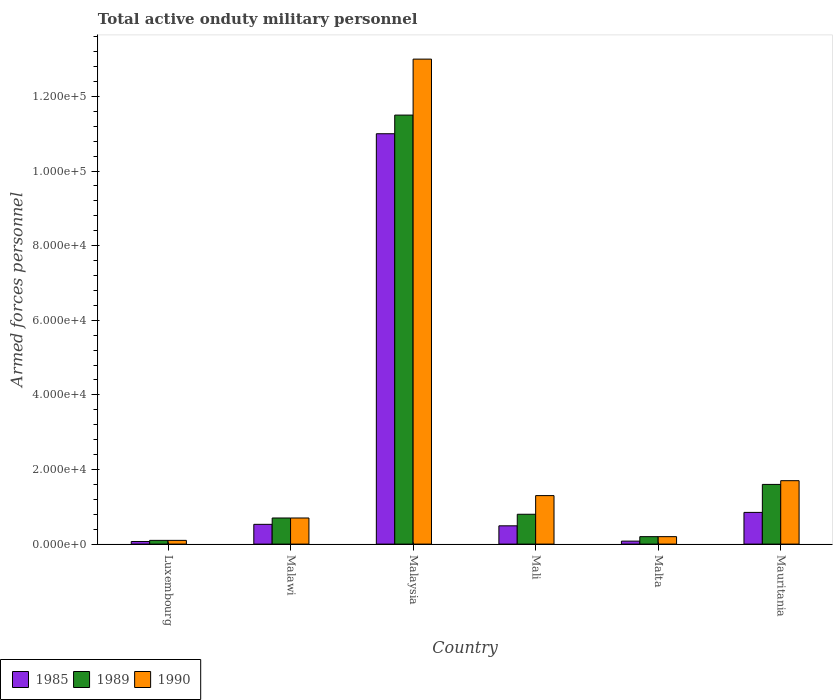Are the number of bars per tick equal to the number of legend labels?
Offer a very short reply. Yes. Are the number of bars on each tick of the X-axis equal?
Give a very brief answer. Yes. What is the label of the 6th group of bars from the left?
Keep it short and to the point. Mauritania. What is the number of armed forces personnel in 1989 in Luxembourg?
Your answer should be compact. 1000. Across all countries, what is the maximum number of armed forces personnel in 1985?
Give a very brief answer. 1.10e+05. In which country was the number of armed forces personnel in 1990 maximum?
Your answer should be compact. Malaysia. In which country was the number of armed forces personnel in 1990 minimum?
Give a very brief answer. Luxembourg. What is the total number of armed forces personnel in 1985 in the graph?
Offer a very short reply. 1.30e+05. What is the difference between the number of armed forces personnel in 1989 in Luxembourg and that in Malta?
Provide a succinct answer. -1000. What is the difference between the number of armed forces personnel in 1989 in Mali and the number of armed forces personnel in 1985 in Malawi?
Keep it short and to the point. 2700. What is the average number of armed forces personnel in 1985 per country?
Make the answer very short. 2.17e+04. What is the difference between the number of armed forces personnel of/in 1985 and number of armed forces personnel of/in 1990 in Malta?
Ensure brevity in your answer.  -1200. What is the difference between the highest and the second highest number of armed forces personnel in 1985?
Your response must be concise. 1.05e+05. What is the difference between the highest and the lowest number of armed forces personnel in 1990?
Ensure brevity in your answer.  1.29e+05. Is the sum of the number of armed forces personnel in 1990 in Luxembourg and Malaysia greater than the maximum number of armed forces personnel in 1985 across all countries?
Your answer should be compact. Yes. What does the 3rd bar from the left in Malaysia represents?
Ensure brevity in your answer.  1990. Is it the case that in every country, the sum of the number of armed forces personnel in 1990 and number of armed forces personnel in 1985 is greater than the number of armed forces personnel in 1989?
Your response must be concise. Yes. How many bars are there?
Make the answer very short. 18. Are all the bars in the graph horizontal?
Provide a succinct answer. No. How many countries are there in the graph?
Provide a succinct answer. 6. Where does the legend appear in the graph?
Give a very brief answer. Bottom left. How many legend labels are there?
Give a very brief answer. 3. How are the legend labels stacked?
Provide a short and direct response. Horizontal. What is the title of the graph?
Keep it short and to the point. Total active onduty military personnel. What is the label or title of the X-axis?
Your answer should be compact. Country. What is the label or title of the Y-axis?
Your answer should be compact. Armed forces personnel. What is the Armed forces personnel of 1985 in Luxembourg?
Give a very brief answer. 700. What is the Armed forces personnel in 1990 in Luxembourg?
Your answer should be compact. 1000. What is the Armed forces personnel in 1985 in Malawi?
Your response must be concise. 5300. What is the Armed forces personnel in 1989 in Malawi?
Provide a succinct answer. 7000. What is the Armed forces personnel of 1990 in Malawi?
Ensure brevity in your answer.  7000. What is the Armed forces personnel of 1985 in Malaysia?
Your response must be concise. 1.10e+05. What is the Armed forces personnel in 1989 in Malaysia?
Offer a very short reply. 1.15e+05. What is the Armed forces personnel of 1990 in Malaysia?
Keep it short and to the point. 1.30e+05. What is the Armed forces personnel in 1985 in Mali?
Give a very brief answer. 4900. What is the Armed forces personnel of 1989 in Mali?
Make the answer very short. 8000. What is the Armed forces personnel of 1990 in Mali?
Make the answer very short. 1.30e+04. What is the Armed forces personnel in 1985 in Malta?
Offer a terse response. 800. What is the Armed forces personnel of 1989 in Malta?
Your answer should be compact. 2000. What is the Armed forces personnel of 1990 in Malta?
Offer a terse response. 2000. What is the Armed forces personnel of 1985 in Mauritania?
Make the answer very short. 8500. What is the Armed forces personnel of 1989 in Mauritania?
Your response must be concise. 1.60e+04. What is the Armed forces personnel in 1990 in Mauritania?
Provide a short and direct response. 1.70e+04. Across all countries, what is the maximum Armed forces personnel in 1985?
Offer a very short reply. 1.10e+05. Across all countries, what is the maximum Armed forces personnel in 1989?
Give a very brief answer. 1.15e+05. Across all countries, what is the maximum Armed forces personnel of 1990?
Provide a short and direct response. 1.30e+05. Across all countries, what is the minimum Armed forces personnel in 1985?
Your response must be concise. 700. Across all countries, what is the minimum Armed forces personnel in 1989?
Keep it short and to the point. 1000. What is the total Armed forces personnel of 1985 in the graph?
Offer a terse response. 1.30e+05. What is the total Armed forces personnel in 1989 in the graph?
Your answer should be compact. 1.49e+05. What is the difference between the Armed forces personnel in 1985 in Luxembourg and that in Malawi?
Ensure brevity in your answer.  -4600. What is the difference between the Armed forces personnel of 1989 in Luxembourg and that in Malawi?
Provide a succinct answer. -6000. What is the difference between the Armed forces personnel in 1990 in Luxembourg and that in Malawi?
Give a very brief answer. -6000. What is the difference between the Armed forces personnel of 1985 in Luxembourg and that in Malaysia?
Provide a succinct answer. -1.09e+05. What is the difference between the Armed forces personnel in 1989 in Luxembourg and that in Malaysia?
Your answer should be very brief. -1.14e+05. What is the difference between the Armed forces personnel in 1990 in Luxembourg and that in Malaysia?
Your response must be concise. -1.29e+05. What is the difference between the Armed forces personnel of 1985 in Luxembourg and that in Mali?
Give a very brief answer. -4200. What is the difference between the Armed forces personnel in 1989 in Luxembourg and that in Mali?
Offer a very short reply. -7000. What is the difference between the Armed forces personnel in 1990 in Luxembourg and that in Mali?
Your answer should be compact. -1.20e+04. What is the difference between the Armed forces personnel of 1985 in Luxembourg and that in Malta?
Provide a succinct answer. -100. What is the difference between the Armed forces personnel of 1989 in Luxembourg and that in Malta?
Offer a terse response. -1000. What is the difference between the Armed forces personnel of 1990 in Luxembourg and that in Malta?
Keep it short and to the point. -1000. What is the difference between the Armed forces personnel of 1985 in Luxembourg and that in Mauritania?
Ensure brevity in your answer.  -7800. What is the difference between the Armed forces personnel of 1989 in Luxembourg and that in Mauritania?
Give a very brief answer. -1.50e+04. What is the difference between the Armed forces personnel in 1990 in Luxembourg and that in Mauritania?
Your answer should be very brief. -1.60e+04. What is the difference between the Armed forces personnel in 1985 in Malawi and that in Malaysia?
Your response must be concise. -1.05e+05. What is the difference between the Armed forces personnel in 1989 in Malawi and that in Malaysia?
Make the answer very short. -1.08e+05. What is the difference between the Armed forces personnel of 1990 in Malawi and that in Malaysia?
Give a very brief answer. -1.23e+05. What is the difference between the Armed forces personnel of 1989 in Malawi and that in Mali?
Provide a short and direct response. -1000. What is the difference between the Armed forces personnel in 1990 in Malawi and that in Mali?
Your answer should be compact. -6000. What is the difference between the Armed forces personnel in 1985 in Malawi and that in Malta?
Keep it short and to the point. 4500. What is the difference between the Armed forces personnel of 1989 in Malawi and that in Malta?
Ensure brevity in your answer.  5000. What is the difference between the Armed forces personnel in 1985 in Malawi and that in Mauritania?
Offer a very short reply. -3200. What is the difference between the Armed forces personnel of 1989 in Malawi and that in Mauritania?
Your response must be concise. -9000. What is the difference between the Armed forces personnel of 1985 in Malaysia and that in Mali?
Keep it short and to the point. 1.05e+05. What is the difference between the Armed forces personnel in 1989 in Malaysia and that in Mali?
Keep it short and to the point. 1.07e+05. What is the difference between the Armed forces personnel of 1990 in Malaysia and that in Mali?
Your answer should be very brief. 1.17e+05. What is the difference between the Armed forces personnel of 1985 in Malaysia and that in Malta?
Offer a terse response. 1.09e+05. What is the difference between the Armed forces personnel of 1989 in Malaysia and that in Malta?
Provide a short and direct response. 1.13e+05. What is the difference between the Armed forces personnel in 1990 in Malaysia and that in Malta?
Provide a short and direct response. 1.28e+05. What is the difference between the Armed forces personnel of 1985 in Malaysia and that in Mauritania?
Give a very brief answer. 1.02e+05. What is the difference between the Armed forces personnel in 1989 in Malaysia and that in Mauritania?
Your answer should be very brief. 9.90e+04. What is the difference between the Armed forces personnel in 1990 in Malaysia and that in Mauritania?
Ensure brevity in your answer.  1.13e+05. What is the difference between the Armed forces personnel of 1985 in Mali and that in Malta?
Give a very brief answer. 4100. What is the difference between the Armed forces personnel in 1989 in Mali and that in Malta?
Offer a terse response. 6000. What is the difference between the Armed forces personnel of 1990 in Mali and that in Malta?
Ensure brevity in your answer.  1.10e+04. What is the difference between the Armed forces personnel in 1985 in Mali and that in Mauritania?
Ensure brevity in your answer.  -3600. What is the difference between the Armed forces personnel in 1989 in Mali and that in Mauritania?
Give a very brief answer. -8000. What is the difference between the Armed forces personnel in 1990 in Mali and that in Mauritania?
Your answer should be very brief. -4000. What is the difference between the Armed forces personnel in 1985 in Malta and that in Mauritania?
Your answer should be very brief. -7700. What is the difference between the Armed forces personnel in 1989 in Malta and that in Mauritania?
Offer a very short reply. -1.40e+04. What is the difference between the Armed forces personnel in 1990 in Malta and that in Mauritania?
Keep it short and to the point. -1.50e+04. What is the difference between the Armed forces personnel of 1985 in Luxembourg and the Armed forces personnel of 1989 in Malawi?
Your response must be concise. -6300. What is the difference between the Armed forces personnel in 1985 in Luxembourg and the Armed forces personnel in 1990 in Malawi?
Ensure brevity in your answer.  -6300. What is the difference between the Armed forces personnel of 1989 in Luxembourg and the Armed forces personnel of 1990 in Malawi?
Make the answer very short. -6000. What is the difference between the Armed forces personnel of 1985 in Luxembourg and the Armed forces personnel of 1989 in Malaysia?
Ensure brevity in your answer.  -1.14e+05. What is the difference between the Armed forces personnel in 1985 in Luxembourg and the Armed forces personnel in 1990 in Malaysia?
Your answer should be compact. -1.29e+05. What is the difference between the Armed forces personnel in 1989 in Luxembourg and the Armed forces personnel in 1990 in Malaysia?
Your response must be concise. -1.29e+05. What is the difference between the Armed forces personnel in 1985 in Luxembourg and the Armed forces personnel in 1989 in Mali?
Provide a short and direct response. -7300. What is the difference between the Armed forces personnel in 1985 in Luxembourg and the Armed forces personnel in 1990 in Mali?
Provide a short and direct response. -1.23e+04. What is the difference between the Armed forces personnel in 1989 in Luxembourg and the Armed forces personnel in 1990 in Mali?
Your answer should be very brief. -1.20e+04. What is the difference between the Armed forces personnel of 1985 in Luxembourg and the Armed forces personnel of 1989 in Malta?
Ensure brevity in your answer.  -1300. What is the difference between the Armed forces personnel of 1985 in Luxembourg and the Armed forces personnel of 1990 in Malta?
Ensure brevity in your answer.  -1300. What is the difference between the Armed forces personnel of 1989 in Luxembourg and the Armed forces personnel of 1990 in Malta?
Your answer should be very brief. -1000. What is the difference between the Armed forces personnel of 1985 in Luxembourg and the Armed forces personnel of 1989 in Mauritania?
Your answer should be very brief. -1.53e+04. What is the difference between the Armed forces personnel in 1985 in Luxembourg and the Armed forces personnel in 1990 in Mauritania?
Keep it short and to the point. -1.63e+04. What is the difference between the Armed forces personnel of 1989 in Luxembourg and the Armed forces personnel of 1990 in Mauritania?
Keep it short and to the point. -1.60e+04. What is the difference between the Armed forces personnel of 1985 in Malawi and the Armed forces personnel of 1989 in Malaysia?
Ensure brevity in your answer.  -1.10e+05. What is the difference between the Armed forces personnel in 1985 in Malawi and the Armed forces personnel in 1990 in Malaysia?
Your answer should be very brief. -1.25e+05. What is the difference between the Armed forces personnel in 1989 in Malawi and the Armed forces personnel in 1990 in Malaysia?
Your answer should be very brief. -1.23e+05. What is the difference between the Armed forces personnel in 1985 in Malawi and the Armed forces personnel in 1989 in Mali?
Give a very brief answer. -2700. What is the difference between the Armed forces personnel of 1985 in Malawi and the Armed forces personnel of 1990 in Mali?
Give a very brief answer. -7700. What is the difference between the Armed forces personnel of 1989 in Malawi and the Armed forces personnel of 1990 in Mali?
Provide a succinct answer. -6000. What is the difference between the Armed forces personnel in 1985 in Malawi and the Armed forces personnel in 1989 in Malta?
Make the answer very short. 3300. What is the difference between the Armed forces personnel in 1985 in Malawi and the Armed forces personnel in 1990 in Malta?
Make the answer very short. 3300. What is the difference between the Armed forces personnel in 1985 in Malawi and the Armed forces personnel in 1989 in Mauritania?
Provide a succinct answer. -1.07e+04. What is the difference between the Armed forces personnel in 1985 in Malawi and the Armed forces personnel in 1990 in Mauritania?
Your answer should be compact. -1.17e+04. What is the difference between the Armed forces personnel in 1989 in Malawi and the Armed forces personnel in 1990 in Mauritania?
Ensure brevity in your answer.  -10000. What is the difference between the Armed forces personnel in 1985 in Malaysia and the Armed forces personnel in 1989 in Mali?
Ensure brevity in your answer.  1.02e+05. What is the difference between the Armed forces personnel in 1985 in Malaysia and the Armed forces personnel in 1990 in Mali?
Make the answer very short. 9.70e+04. What is the difference between the Armed forces personnel of 1989 in Malaysia and the Armed forces personnel of 1990 in Mali?
Keep it short and to the point. 1.02e+05. What is the difference between the Armed forces personnel in 1985 in Malaysia and the Armed forces personnel in 1989 in Malta?
Ensure brevity in your answer.  1.08e+05. What is the difference between the Armed forces personnel of 1985 in Malaysia and the Armed forces personnel of 1990 in Malta?
Offer a terse response. 1.08e+05. What is the difference between the Armed forces personnel in 1989 in Malaysia and the Armed forces personnel in 1990 in Malta?
Your answer should be very brief. 1.13e+05. What is the difference between the Armed forces personnel of 1985 in Malaysia and the Armed forces personnel of 1989 in Mauritania?
Your answer should be very brief. 9.40e+04. What is the difference between the Armed forces personnel in 1985 in Malaysia and the Armed forces personnel in 1990 in Mauritania?
Offer a very short reply. 9.30e+04. What is the difference between the Armed forces personnel in 1989 in Malaysia and the Armed forces personnel in 1990 in Mauritania?
Your answer should be very brief. 9.80e+04. What is the difference between the Armed forces personnel in 1985 in Mali and the Armed forces personnel in 1989 in Malta?
Your answer should be very brief. 2900. What is the difference between the Armed forces personnel of 1985 in Mali and the Armed forces personnel of 1990 in Malta?
Your response must be concise. 2900. What is the difference between the Armed forces personnel of 1989 in Mali and the Armed forces personnel of 1990 in Malta?
Provide a succinct answer. 6000. What is the difference between the Armed forces personnel in 1985 in Mali and the Armed forces personnel in 1989 in Mauritania?
Make the answer very short. -1.11e+04. What is the difference between the Armed forces personnel in 1985 in Mali and the Armed forces personnel in 1990 in Mauritania?
Make the answer very short. -1.21e+04. What is the difference between the Armed forces personnel in 1989 in Mali and the Armed forces personnel in 1990 in Mauritania?
Keep it short and to the point. -9000. What is the difference between the Armed forces personnel of 1985 in Malta and the Armed forces personnel of 1989 in Mauritania?
Make the answer very short. -1.52e+04. What is the difference between the Armed forces personnel of 1985 in Malta and the Armed forces personnel of 1990 in Mauritania?
Your answer should be very brief. -1.62e+04. What is the difference between the Armed forces personnel in 1989 in Malta and the Armed forces personnel in 1990 in Mauritania?
Offer a terse response. -1.50e+04. What is the average Armed forces personnel of 1985 per country?
Offer a very short reply. 2.17e+04. What is the average Armed forces personnel of 1989 per country?
Make the answer very short. 2.48e+04. What is the average Armed forces personnel in 1990 per country?
Offer a very short reply. 2.83e+04. What is the difference between the Armed forces personnel in 1985 and Armed forces personnel in 1989 in Luxembourg?
Provide a succinct answer. -300. What is the difference between the Armed forces personnel in 1985 and Armed forces personnel in 1990 in Luxembourg?
Offer a terse response. -300. What is the difference between the Armed forces personnel in 1985 and Armed forces personnel in 1989 in Malawi?
Provide a short and direct response. -1700. What is the difference between the Armed forces personnel of 1985 and Armed forces personnel of 1990 in Malawi?
Your answer should be very brief. -1700. What is the difference between the Armed forces personnel in 1989 and Armed forces personnel in 1990 in Malawi?
Keep it short and to the point. 0. What is the difference between the Armed forces personnel of 1985 and Armed forces personnel of 1989 in Malaysia?
Make the answer very short. -5000. What is the difference between the Armed forces personnel of 1989 and Armed forces personnel of 1990 in Malaysia?
Make the answer very short. -1.50e+04. What is the difference between the Armed forces personnel of 1985 and Armed forces personnel of 1989 in Mali?
Your answer should be compact. -3100. What is the difference between the Armed forces personnel of 1985 and Armed forces personnel of 1990 in Mali?
Make the answer very short. -8100. What is the difference between the Armed forces personnel in 1989 and Armed forces personnel in 1990 in Mali?
Offer a terse response. -5000. What is the difference between the Armed forces personnel of 1985 and Armed forces personnel of 1989 in Malta?
Keep it short and to the point. -1200. What is the difference between the Armed forces personnel in 1985 and Armed forces personnel in 1990 in Malta?
Make the answer very short. -1200. What is the difference between the Armed forces personnel in 1989 and Armed forces personnel in 1990 in Malta?
Offer a very short reply. 0. What is the difference between the Armed forces personnel in 1985 and Armed forces personnel in 1989 in Mauritania?
Offer a terse response. -7500. What is the difference between the Armed forces personnel in 1985 and Armed forces personnel in 1990 in Mauritania?
Offer a very short reply. -8500. What is the difference between the Armed forces personnel in 1989 and Armed forces personnel in 1990 in Mauritania?
Provide a short and direct response. -1000. What is the ratio of the Armed forces personnel of 1985 in Luxembourg to that in Malawi?
Make the answer very short. 0.13. What is the ratio of the Armed forces personnel of 1989 in Luxembourg to that in Malawi?
Give a very brief answer. 0.14. What is the ratio of the Armed forces personnel of 1990 in Luxembourg to that in Malawi?
Make the answer very short. 0.14. What is the ratio of the Armed forces personnel of 1985 in Luxembourg to that in Malaysia?
Give a very brief answer. 0.01. What is the ratio of the Armed forces personnel of 1989 in Luxembourg to that in Malaysia?
Your answer should be compact. 0.01. What is the ratio of the Armed forces personnel in 1990 in Luxembourg to that in Malaysia?
Make the answer very short. 0.01. What is the ratio of the Armed forces personnel of 1985 in Luxembourg to that in Mali?
Keep it short and to the point. 0.14. What is the ratio of the Armed forces personnel in 1990 in Luxembourg to that in Mali?
Ensure brevity in your answer.  0.08. What is the ratio of the Armed forces personnel of 1985 in Luxembourg to that in Mauritania?
Your answer should be very brief. 0.08. What is the ratio of the Armed forces personnel in 1989 in Luxembourg to that in Mauritania?
Provide a short and direct response. 0.06. What is the ratio of the Armed forces personnel in 1990 in Luxembourg to that in Mauritania?
Provide a succinct answer. 0.06. What is the ratio of the Armed forces personnel in 1985 in Malawi to that in Malaysia?
Your answer should be very brief. 0.05. What is the ratio of the Armed forces personnel in 1989 in Malawi to that in Malaysia?
Make the answer very short. 0.06. What is the ratio of the Armed forces personnel of 1990 in Malawi to that in Malaysia?
Your answer should be very brief. 0.05. What is the ratio of the Armed forces personnel of 1985 in Malawi to that in Mali?
Ensure brevity in your answer.  1.08. What is the ratio of the Armed forces personnel of 1990 in Malawi to that in Mali?
Ensure brevity in your answer.  0.54. What is the ratio of the Armed forces personnel of 1985 in Malawi to that in Malta?
Ensure brevity in your answer.  6.62. What is the ratio of the Armed forces personnel in 1985 in Malawi to that in Mauritania?
Provide a short and direct response. 0.62. What is the ratio of the Armed forces personnel of 1989 in Malawi to that in Mauritania?
Ensure brevity in your answer.  0.44. What is the ratio of the Armed forces personnel in 1990 in Malawi to that in Mauritania?
Your response must be concise. 0.41. What is the ratio of the Armed forces personnel of 1985 in Malaysia to that in Mali?
Keep it short and to the point. 22.45. What is the ratio of the Armed forces personnel in 1989 in Malaysia to that in Mali?
Ensure brevity in your answer.  14.38. What is the ratio of the Armed forces personnel of 1985 in Malaysia to that in Malta?
Offer a very short reply. 137.5. What is the ratio of the Armed forces personnel of 1989 in Malaysia to that in Malta?
Keep it short and to the point. 57.5. What is the ratio of the Armed forces personnel of 1990 in Malaysia to that in Malta?
Provide a short and direct response. 65. What is the ratio of the Armed forces personnel in 1985 in Malaysia to that in Mauritania?
Give a very brief answer. 12.94. What is the ratio of the Armed forces personnel in 1989 in Malaysia to that in Mauritania?
Make the answer very short. 7.19. What is the ratio of the Armed forces personnel in 1990 in Malaysia to that in Mauritania?
Keep it short and to the point. 7.65. What is the ratio of the Armed forces personnel in 1985 in Mali to that in Malta?
Your response must be concise. 6.12. What is the ratio of the Armed forces personnel in 1989 in Mali to that in Malta?
Make the answer very short. 4. What is the ratio of the Armed forces personnel in 1985 in Mali to that in Mauritania?
Provide a short and direct response. 0.58. What is the ratio of the Armed forces personnel in 1989 in Mali to that in Mauritania?
Keep it short and to the point. 0.5. What is the ratio of the Armed forces personnel in 1990 in Mali to that in Mauritania?
Provide a short and direct response. 0.76. What is the ratio of the Armed forces personnel in 1985 in Malta to that in Mauritania?
Provide a short and direct response. 0.09. What is the ratio of the Armed forces personnel in 1990 in Malta to that in Mauritania?
Your response must be concise. 0.12. What is the difference between the highest and the second highest Armed forces personnel in 1985?
Offer a very short reply. 1.02e+05. What is the difference between the highest and the second highest Armed forces personnel of 1989?
Provide a succinct answer. 9.90e+04. What is the difference between the highest and the second highest Armed forces personnel in 1990?
Your answer should be compact. 1.13e+05. What is the difference between the highest and the lowest Armed forces personnel in 1985?
Keep it short and to the point. 1.09e+05. What is the difference between the highest and the lowest Armed forces personnel in 1989?
Provide a succinct answer. 1.14e+05. What is the difference between the highest and the lowest Armed forces personnel in 1990?
Offer a very short reply. 1.29e+05. 